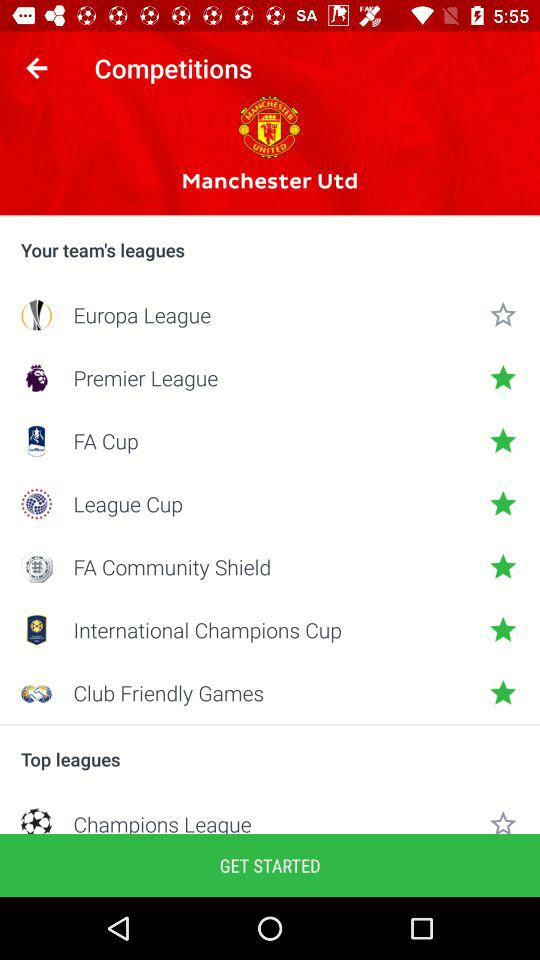Which team don't receive any star?
When the provided information is insufficient, respond with <no answer>. <no answer> 